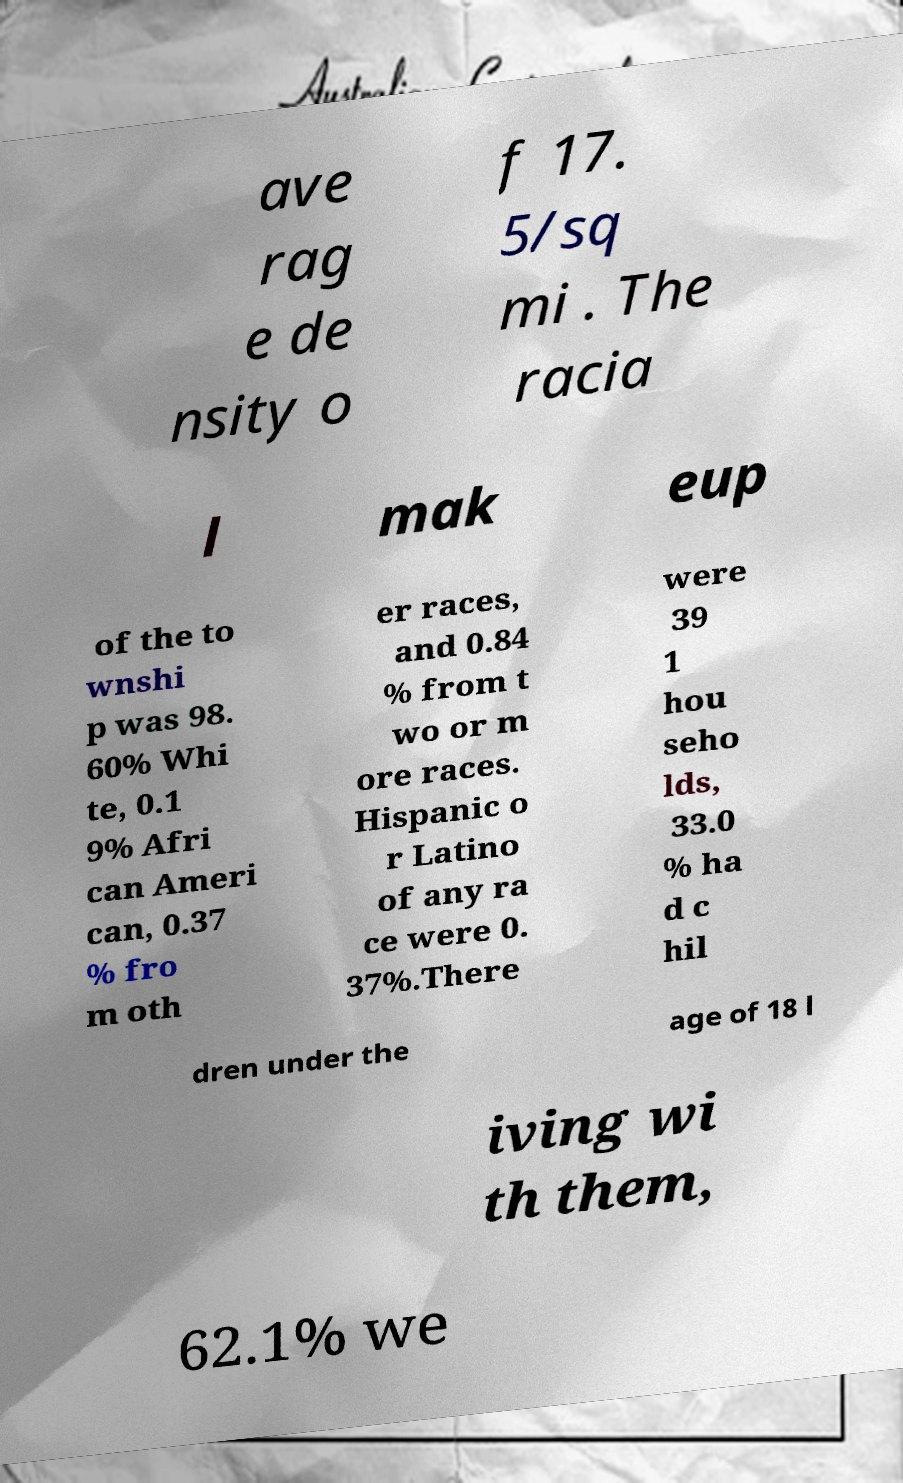Please identify and transcribe the text found in this image. ave rag e de nsity o f 17. 5/sq mi . The racia l mak eup of the to wnshi p was 98. 60% Whi te, 0.1 9% Afri can Ameri can, 0.37 % fro m oth er races, and 0.84 % from t wo or m ore races. Hispanic o r Latino of any ra ce were 0. 37%.There were 39 1 hou seho lds, 33.0 % ha d c hil dren under the age of 18 l iving wi th them, 62.1% we 